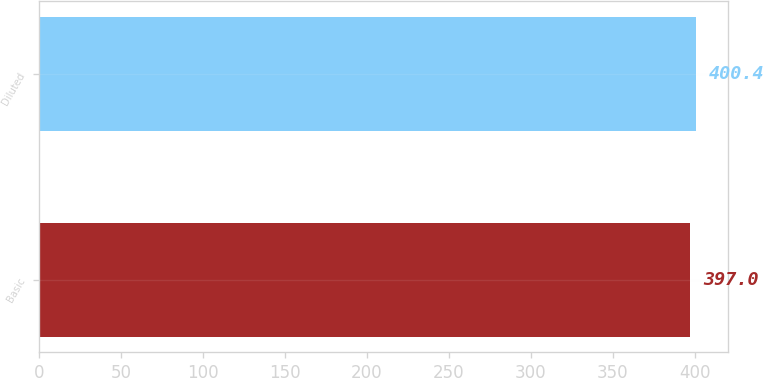Convert chart to OTSL. <chart><loc_0><loc_0><loc_500><loc_500><bar_chart><fcel>Basic<fcel>Diluted<nl><fcel>397<fcel>400.4<nl></chart> 